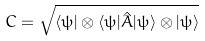<formula> <loc_0><loc_0><loc_500><loc_500>C = \sqrt { \langle \psi | \otimes \langle \psi | \hat { A } | \psi \rangle \otimes | \psi \rangle }</formula> 